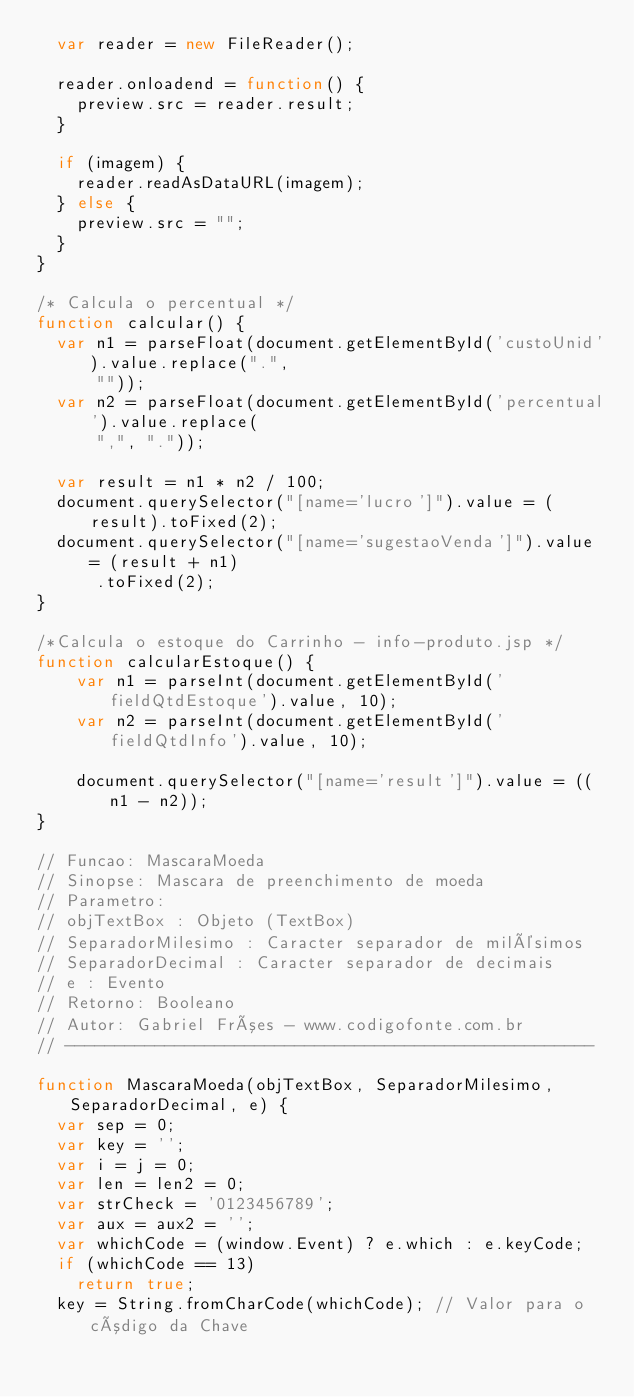<code> <loc_0><loc_0><loc_500><loc_500><_JavaScript_>	var reader = new FileReader();

	reader.onloadend = function() {
		preview.src = reader.result;
	}

	if (imagem) {
		reader.readAsDataURL(imagem);
	} else {
		preview.src = "";
	}
}

/* Calcula o percentual */
function calcular() {
	var n1 = parseFloat(document.getElementById('custoUnid').value.replace(".",
			""));
	var n2 = parseFloat(document.getElementById('percentual').value.replace(
			",", "."));

	var result = n1 * n2 / 100;
	document.querySelector("[name='lucro']").value = (result).toFixed(2);
	document.querySelector("[name='sugestaoVenda']").value = (result + n1)
			.toFixed(2);
}

/*Calcula o estoque do Carrinho - info-produto.jsp */
function calcularEstoque() {
	  var n1 = parseInt(document.getElementById('fieldQtdEstoque').value, 10);
	  var n2 = parseInt(document.getElementById('fieldQtdInfo').value, 10);
	 
	  document.querySelector("[name='result']").value = ((n1 - n2));
}

// Funcao: MascaraMoeda
// Sinopse: Mascara de preenchimento de moeda
// Parametro:
// objTextBox : Objeto (TextBox)
// SeparadorMilesimo : Caracter separador de milésimos
// SeparadorDecimal : Caracter separador de decimais
// e : Evento
// Retorno: Booleano
// Autor: Gabriel Fróes - www.codigofonte.com.br
// -----------------------------------------------------

function MascaraMoeda(objTextBox, SeparadorMilesimo, SeparadorDecimal, e) {
	var sep = 0;
	var key = '';
	var i = j = 0;
	var len = len2 = 0;
	var strCheck = '0123456789';
	var aux = aux2 = '';
	var whichCode = (window.Event) ? e.which : e.keyCode;
	if (whichCode == 13)
		return true;
	key = String.fromCharCode(whichCode); // Valor para o código da Chave</code> 